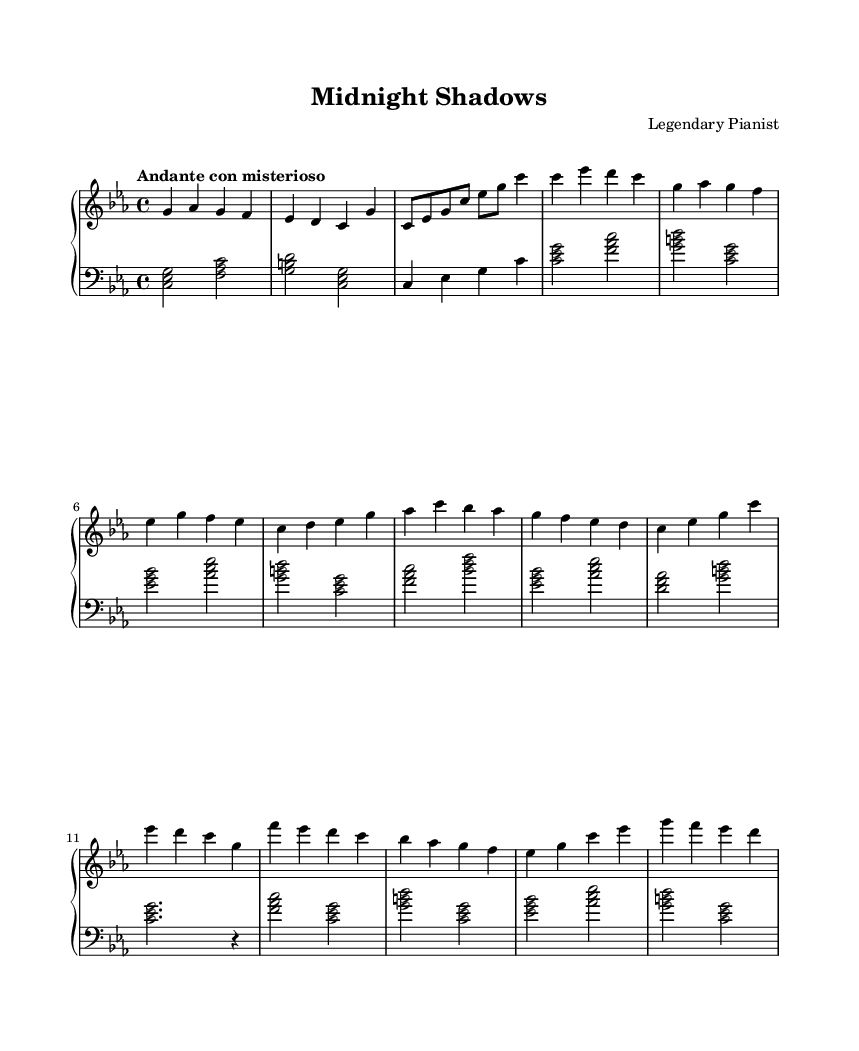What is the key signature of this music? The key signature is C minor, which contains three flats (B flat, E flat, and A flat). This is determined by the presence of the B flat and E flat notes in the bass clef and the overall tonal context of the piece.
Answer: C minor What is the time signature of this music? The time signature is 4/4, indicated at the beginning of the score by the fraction, which shows that there are four beats per measure and the quarter note receives one beat.
Answer: 4/4 What is the tempo marking of this piece? The tempo marking is "Andante con misterioso," which suggests a moderately slow pace with a sense of mystery. This can be found on the first line of the score, showing how the music should be interpreted rhythmically.
Answer: Andante con misterioso How many measures are in section A of the piece? Section A consists of 8 measures. This can be counted by starting from the first measure of section A through to the end of section A, noting each measure when marked.
Answer: 8 What is the highest note in this piece? The highest note in this piece is G. It appears in the right hand part during the introduction and continues to be a prominent note throughout the sections.
Answer: G What is the primary musical texture of this soundtrack? The texture is melodic and harmonic, characterized by a clear distinction between the melodic line played by the right hand and the harmonic support from the left hand. This relationship is typical of jazz-influenced compositions, enhancing the emotional depth of the piece.
Answer: Melodic and harmonic What is the mood conveyed by the phrase "Andante con misterioso"? The mood is mysterious and contemplative, suggesting a sense of intrigue and depth, often associated with noir themes. This can be understood from the tempo marking paired with the musical content, which tends to evoke such feelings.
Answer: Mysterious and contemplative 